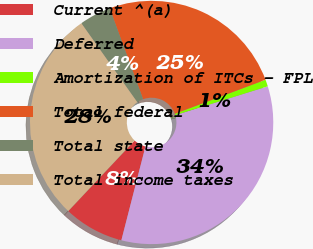<chart> <loc_0><loc_0><loc_500><loc_500><pie_chart><fcel>Current ^(a)<fcel>Deferred<fcel>Amortization of ITCs - FPL<fcel>Total federal<fcel>Total state<fcel>Total income taxes<nl><fcel>8.01%<fcel>33.81%<fcel>0.91%<fcel>24.89%<fcel>4.2%<fcel>28.18%<nl></chart> 